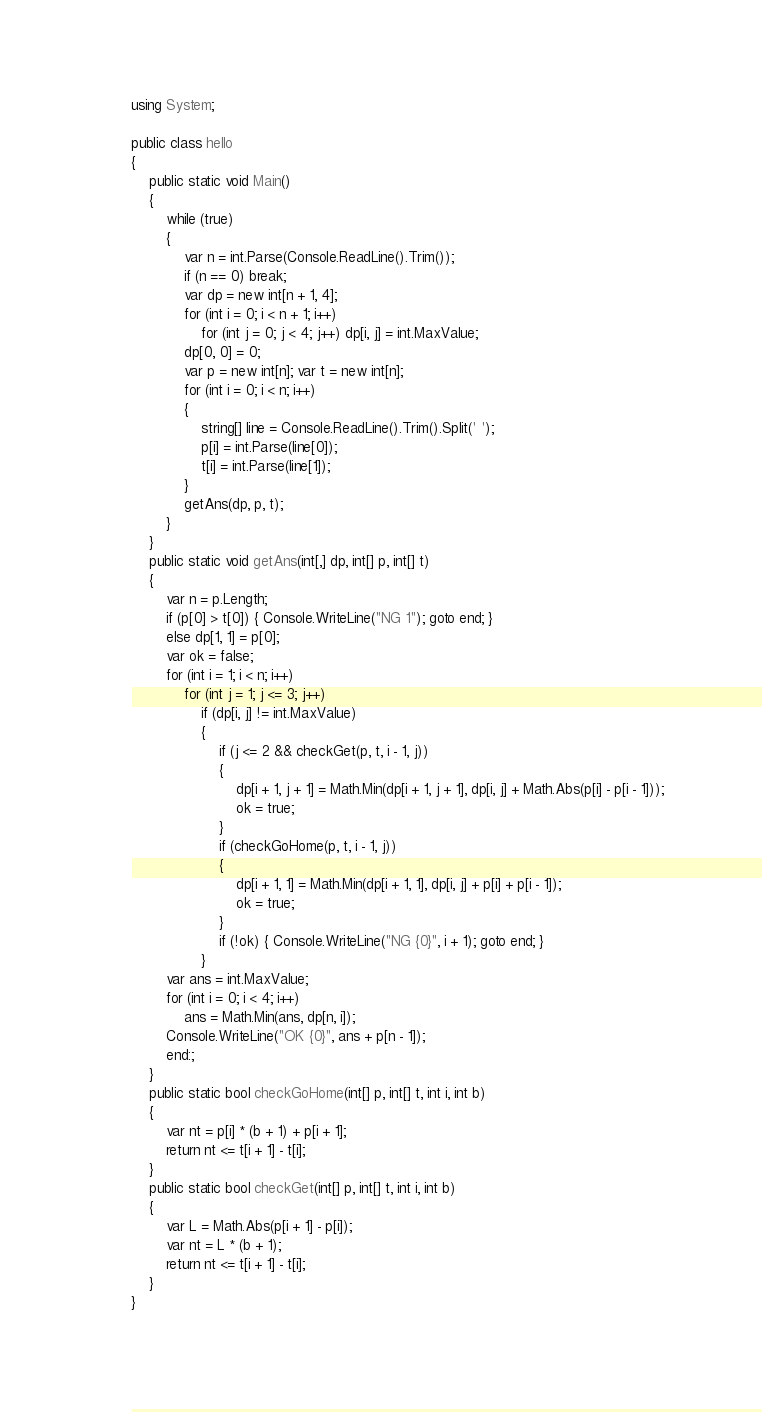<code> <loc_0><loc_0><loc_500><loc_500><_C#_>using System;

public class hello
{
    public static void Main()
    {
        while (true)
        {
            var n = int.Parse(Console.ReadLine().Trim());
            if (n == 0) break;
            var dp = new int[n + 1, 4];
            for (int i = 0; i < n + 1; i++)
                for (int j = 0; j < 4; j++) dp[i, j] = int.MaxValue;
            dp[0, 0] = 0;
            var p = new int[n]; var t = new int[n];
            for (int i = 0; i < n; i++)
            {
                string[] line = Console.ReadLine().Trim().Split(' ');
                p[i] = int.Parse(line[0]);
                t[i] = int.Parse(line[1]);
            }
            getAns(dp, p, t);
        }
    }
    public static void getAns(int[,] dp, int[] p, int[] t)
    {
        var n = p.Length;
        if (p[0] > t[0]) { Console.WriteLine("NG 1"); goto end; }
        else dp[1, 1] = p[0];
        var ok = false;
        for (int i = 1; i < n; i++)
            for (int j = 1; j <= 3; j++)
                if (dp[i, j] != int.MaxValue)
                {
                    if (j <= 2 && checkGet(p, t, i - 1, j))
                    {
                        dp[i + 1, j + 1] = Math.Min(dp[i + 1, j + 1], dp[i, j] + Math.Abs(p[i] - p[i - 1]));
                        ok = true;
                    }
                    if (checkGoHome(p, t, i - 1, j))
                    {
                        dp[i + 1, 1] = Math.Min(dp[i + 1, 1], dp[i, j] + p[i] + p[i - 1]);
                        ok = true;
                    }
                    if (!ok) { Console.WriteLine("NG {0}", i + 1); goto end; }
                }
        var ans = int.MaxValue;
        for (int i = 0; i < 4; i++)
            ans = Math.Min(ans, dp[n, i]);
        Console.WriteLine("OK {0}", ans + p[n - 1]);
        end:;
    }
    public static bool checkGoHome(int[] p, int[] t, int i, int b)
    {
        var nt = p[i] * (b + 1) + p[i + 1];
        return nt <= t[i + 1] - t[i];
    }
    public static bool checkGet(int[] p, int[] t, int i, int b)
    {
        var L = Math.Abs(p[i + 1] - p[i]);
        var nt = L * (b + 1);
        return nt <= t[i + 1] - t[i];
    }
}
</code> 